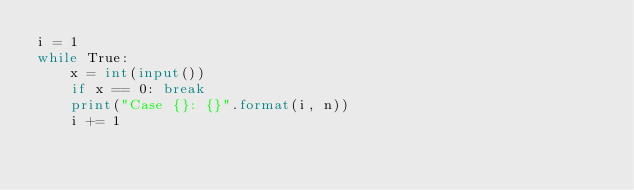<code> <loc_0><loc_0><loc_500><loc_500><_Python_>i = 1
while True:
    x = int(input())
    if x == 0: break
    print("Case {}: {}".format(i, n))
    i += 1
</code> 